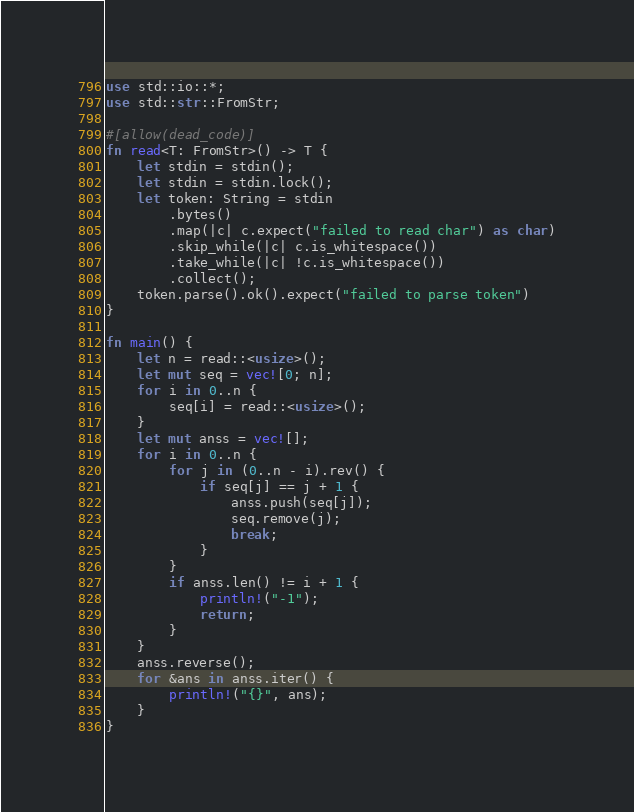Convert code to text. <code><loc_0><loc_0><loc_500><loc_500><_Rust_>use std::io::*;
use std::str::FromStr;

#[allow(dead_code)]
fn read<T: FromStr>() -> T {
    let stdin = stdin();
    let stdin = stdin.lock();
    let token: String = stdin
        .bytes()
        .map(|c| c.expect("failed to read char") as char)
        .skip_while(|c| c.is_whitespace())
        .take_while(|c| !c.is_whitespace())
        .collect();
    token.parse().ok().expect("failed to parse token")
}

fn main() {
    let n = read::<usize>();
    let mut seq = vec![0; n];
    for i in 0..n {
        seq[i] = read::<usize>();
    }
    let mut anss = vec![];
    for i in 0..n {
        for j in (0..n - i).rev() {
            if seq[j] == j + 1 {
                anss.push(seq[j]);
                seq.remove(j);
                break;
            }
        }
        if anss.len() != i + 1 {
            println!("-1");
            return;
        }
    }
    anss.reverse();
    for &ans in anss.iter() {
        println!("{}", ans);
    }
}
</code> 